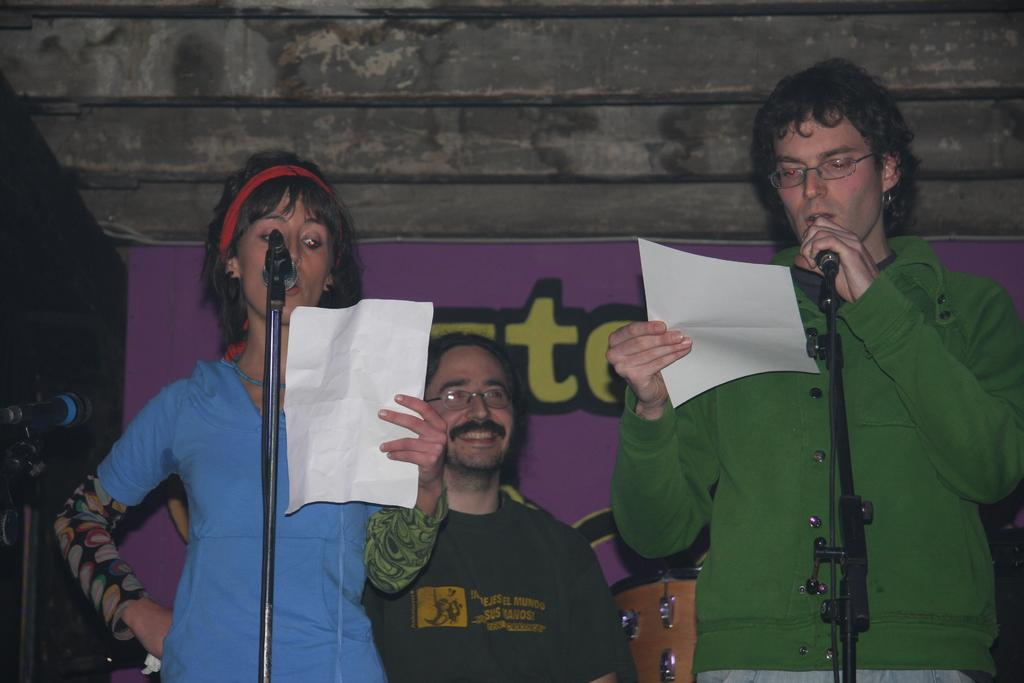What objects are located in the middle of the image? There are microphones in the middle of the image. What are the people behind the microphones doing? The people are standing behind the microphones and holding papers. What can be seen on the wall in the background of the image? There is a banner visible in the image. What is the purpose of the papers the people are holding? The purpose of the papers is not specified, but they might be holding notes or scripts. What type of scent can be detected in the image? There is no information about any scent in the image, as it primarily features microphones, people, and a banner. 